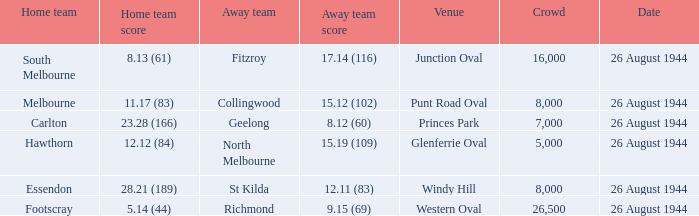What's the mean gathering size when the home team is melbourne? 8000.0. I'm looking to parse the entire table for insights. Could you assist me with that? {'header': ['Home team', 'Home team score', 'Away team', 'Away team score', 'Venue', 'Crowd', 'Date'], 'rows': [['South Melbourne', '8.13 (61)', 'Fitzroy', '17.14 (116)', 'Junction Oval', '16,000', '26 August 1944'], ['Melbourne', '11.17 (83)', 'Collingwood', '15.12 (102)', 'Punt Road Oval', '8,000', '26 August 1944'], ['Carlton', '23.28 (166)', 'Geelong', '8.12 (60)', 'Princes Park', '7,000', '26 August 1944'], ['Hawthorn', '12.12 (84)', 'North Melbourne', '15.19 (109)', 'Glenferrie Oval', '5,000', '26 August 1944'], ['Essendon', '28.21 (189)', 'St Kilda', '12.11 (83)', 'Windy Hill', '8,000', '26 August 1944'], ['Footscray', '5.14 (44)', 'Richmond', '9.15 (69)', 'Western Oval', '26,500', '26 August 1944']]} 